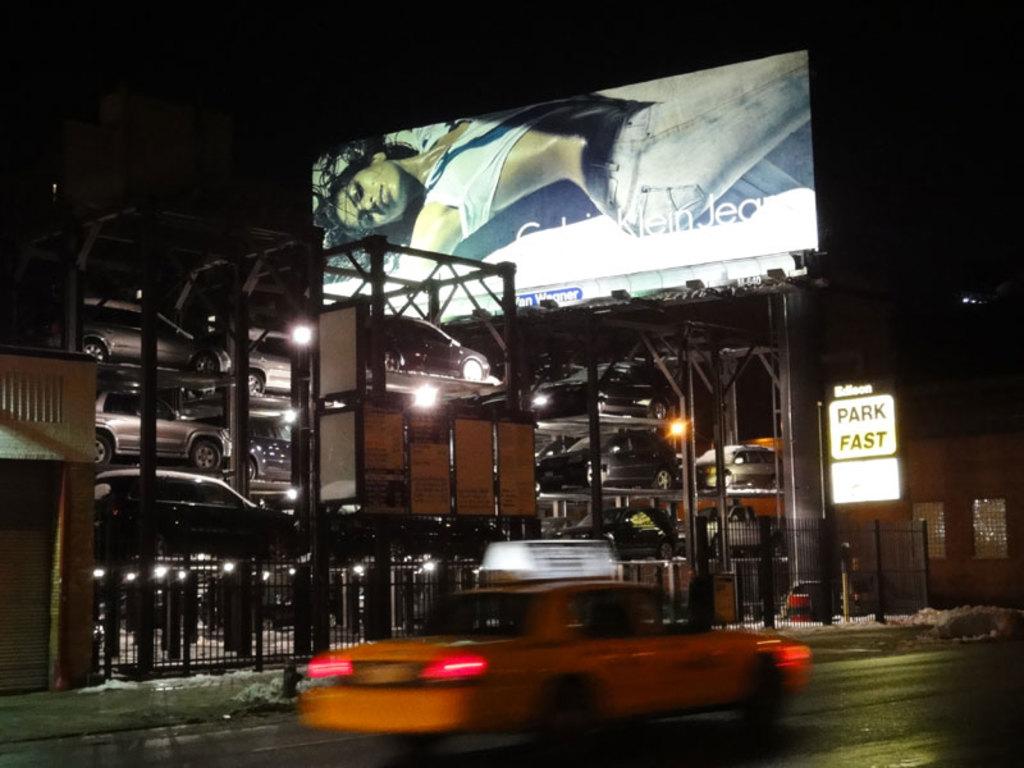What brand is advertised on the billboard?
Your answer should be compact. Calvin klein. What does the white sign say?
Offer a very short reply. Park fast. 